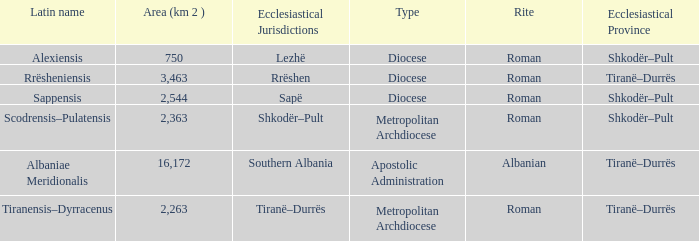What Ecclesiastical Province has a type diocese and a latin name alexiensis? Shkodër–Pult. 